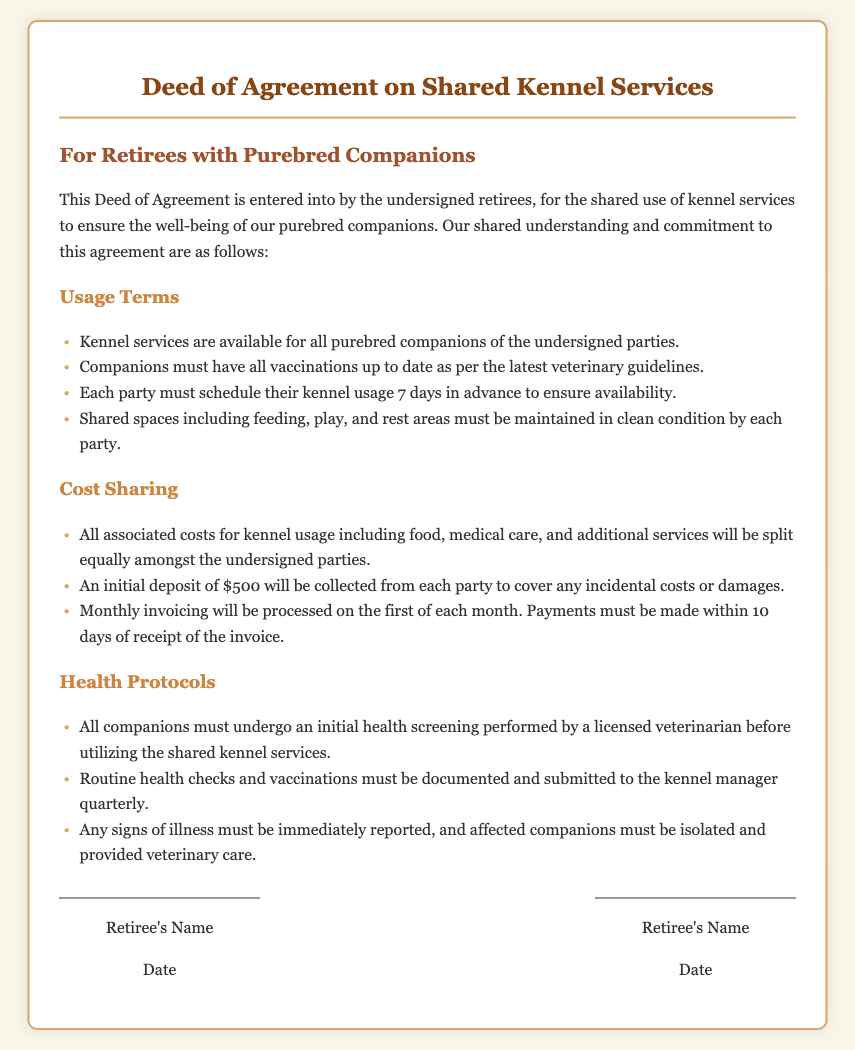What is the title of the document? The title of the document is listed at the top under the heading.
Answer: Deed of Agreement on Shared Kennel Services How many days in advance must kennel usage be scheduled? The document specifies the scheduling time frame in the usage terms section.
Answer: 7 days What is the initial deposit amount required from each party? The cost sharing section states the initial deposit needed for incidental costs.
Answer: $500 What must be performed before utilizing the kennel services? The health protocols mention a prerequisite for using the kennel.
Answer: Initial health screening How often must routine health checks and vaccinations be submitted? The health protocols section specifies the submission frequency.
Answer: Quarterly Who is responsible for maintaining clean conditions in shared spaces? The usage terms clarify the responsibility of each party regarding cleanliness.
Answer: Each party When are monthly invoices processed? The document includes a specific date for invoice processing in the cost sharing section.
Answer: First of each month What must be reported if any signs of illness are observed? The health protocols detail the actions needed in case of illness.
Answer: Immediately reported What type of companions does this agreement apply to? The document specifies the type of pets involved in this agreement.
Answer: Purebred companions 